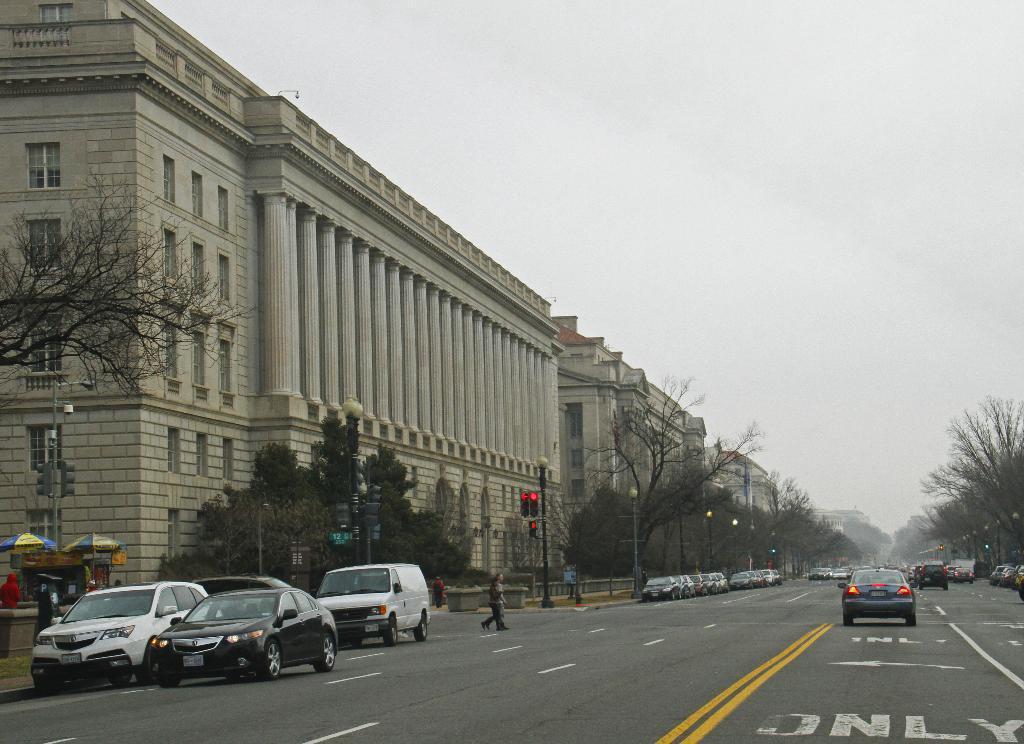Can you describe this image briefly? In this image I can see few buildings, trees, traffic signals, light poles, tents, few vehicles, fencing, poles and few people. The sky is in white color. 